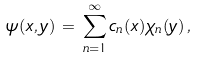Convert formula to latex. <formula><loc_0><loc_0><loc_500><loc_500>\psi ( x , y ) \, = \, \sum _ { n = 1 } ^ { \infty } c _ { n } ( x ) \chi _ { n } ( y ) \, ,</formula> 